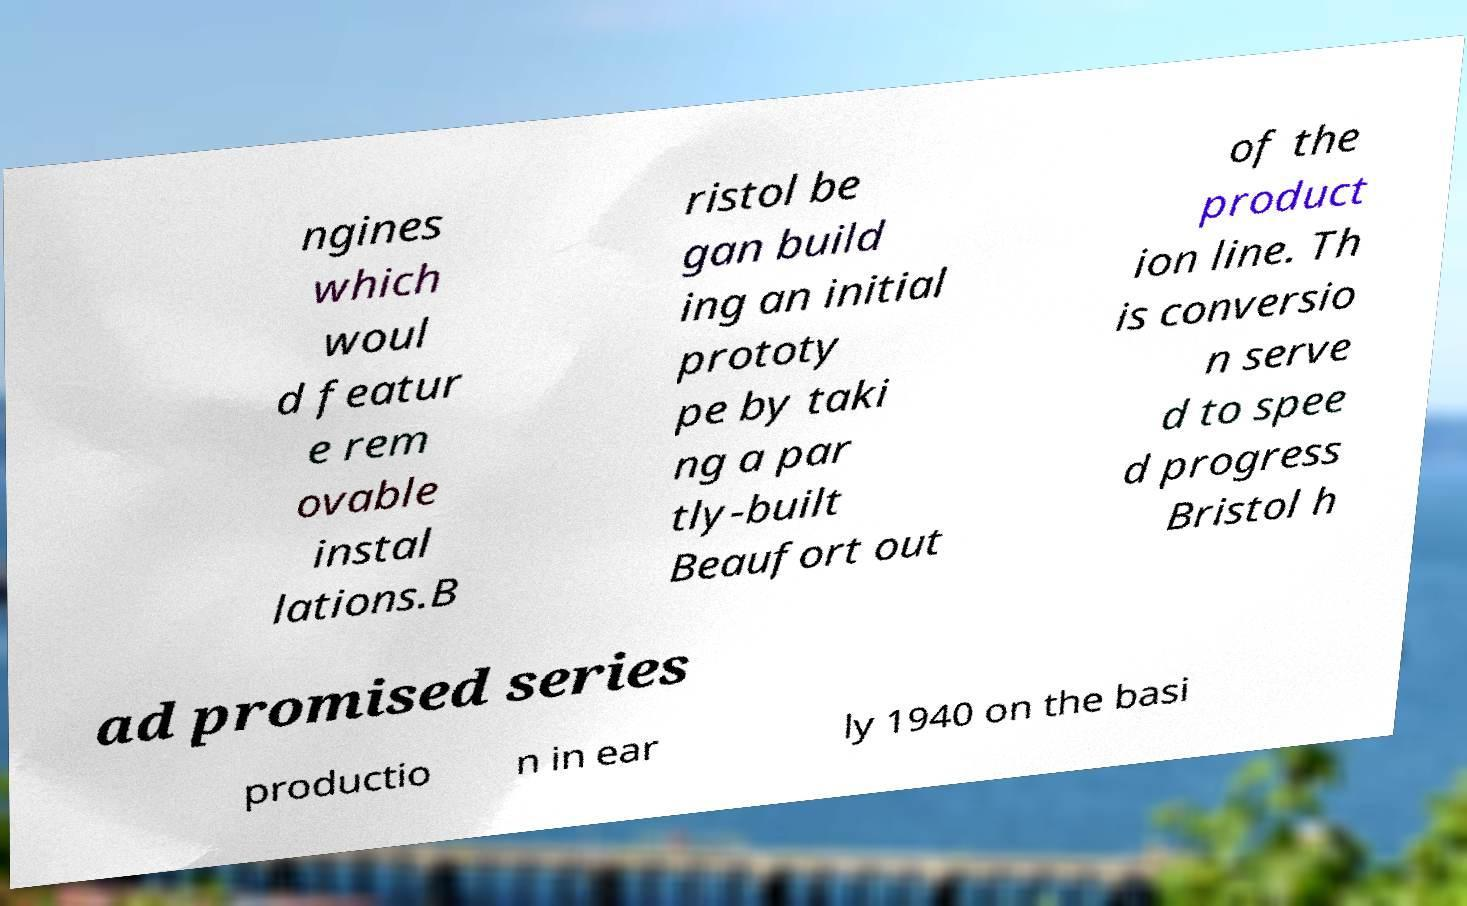Could you extract and type out the text from this image? ngines which woul d featur e rem ovable instal lations.B ristol be gan build ing an initial prototy pe by taki ng a par tly-built Beaufort out of the product ion line. Th is conversio n serve d to spee d progress Bristol h ad promised series productio n in ear ly 1940 on the basi 